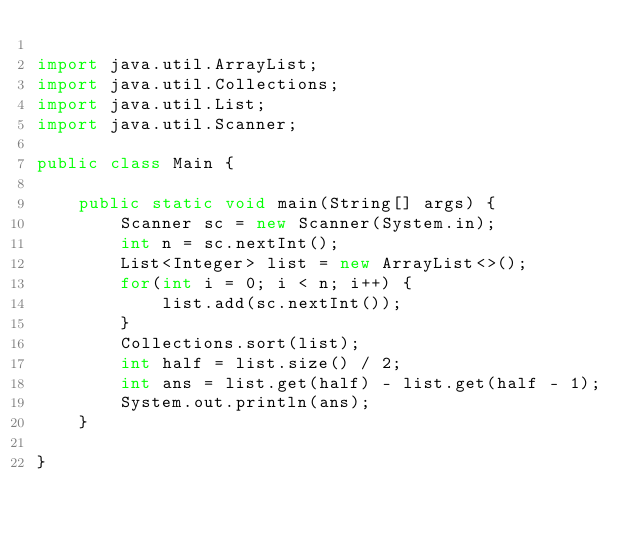<code> <loc_0><loc_0><loc_500><loc_500><_Java_>
import java.util.ArrayList;
import java.util.Collections;
import java.util.List;
import java.util.Scanner;

public class Main {

	public static void main(String[] args) {
		Scanner sc = new Scanner(System.in);
		int n = sc.nextInt();
		List<Integer> list = new ArrayList<>();
		for(int i = 0; i < n; i++) {
			list.add(sc.nextInt());
		}
		Collections.sort(list);
		int half = list.size() / 2;
		int ans = list.get(half) - list.get(half - 1);
		System.out.println(ans);
	}

}
</code> 